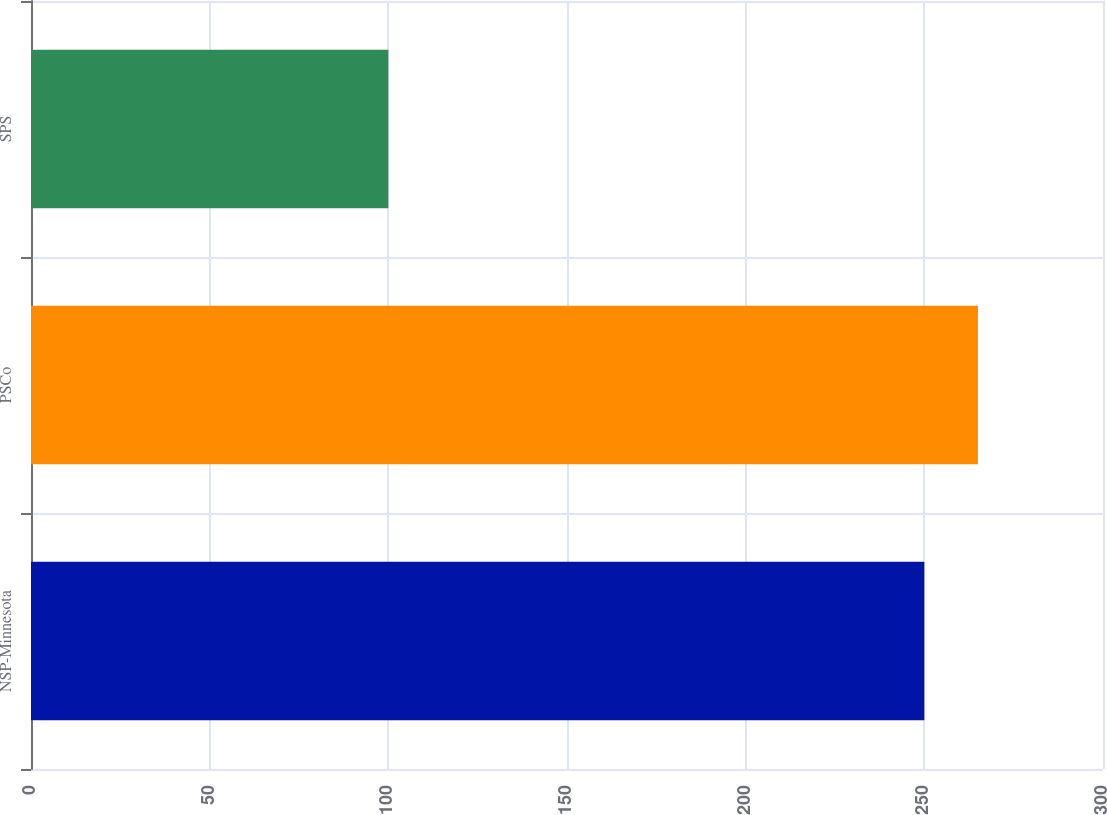Convert chart to OTSL. <chart><loc_0><loc_0><loc_500><loc_500><bar_chart><fcel>NSP-Minnesota<fcel>PSCo<fcel>SPS<nl><fcel>250<fcel>265<fcel>100<nl></chart> 